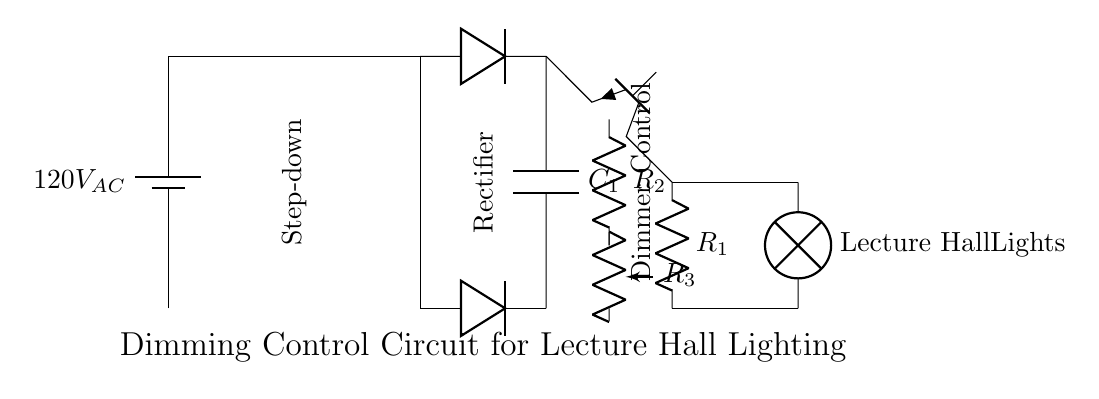What is the input voltage to the circuit? The input voltage is specified as 120V when the power source is drawn in the circuit diagram. This indicates the voltage supplied to the initial components of the circuit.
Answer: 120V What type of component is used for dimming control? The dimming control is implemented using a potentiometer, which allows for adjustable resistance. This component varies the current flowing to the load, thereby controlling the brightness of the connected lights.
Answer: Potentiometer What does the transformer do in this circuit? The transformer serves to step down the voltage from the input AC supply (120V) to a lower AC voltage suitable for the rest of the circuit. This function is essential to prevent damage to other components.
Answer: Step-down What are the two types of diodes used in the circuit? The circuit utilizes two diodes arranged in a rectifier formation, both functioning as signal rectifiers to convert alternating current to direct current. These diodes ensure that the current flow is unidirectional.
Answer: Diodes How many resistors are present in the dimmer control section? In the dimmer control section, there are two fixed resistors (R1 and R2) as well as one adjustable resistor (R3, the potentiometer), making a total of three resistors contributing to the dimming function.
Answer: Three What is the function of the capacitor in the circuit? The capacitor is likely used for filtering out any remaining AC ripples after rectification, thereby providing a smoother DC voltage to the next stages of the circuit, particularly to the dimmer control and lamp.
Answer: Filtering What is the output device connected to this circuit? The output device in this dimming control circuit is the lamp, specifically designated for lecture hall lighting, which demonstrates the practical application of the circuit’s purpose.
Answer: Lecture Hall Lights 